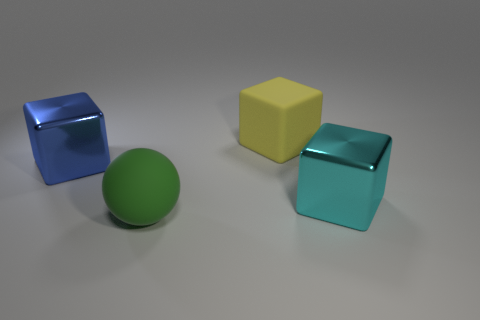Is there a blue thing of the same shape as the yellow matte thing?
Give a very brief answer. Yes. There is a large rubber block; does it have the same color as the cube that is on the left side of the big green matte sphere?
Keep it short and to the point. No. Is there a blue metallic block of the same size as the blue shiny thing?
Provide a succinct answer. No. Are the big yellow block and the cube to the left of the green matte ball made of the same material?
Your answer should be very brief. No. Is the number of yellow matte cylinders greater than the number of spheres?
Your response must be concise. No. How many balls are either small purple things or blue shiny objects?
Provide a succinct answer. 0. What color is the matte sphere?
Your response must be concise. Green. Do the metal object on the left side of the cyan cube and the thing behind the large blue cube have the same size?
Your response must be concise. Yes. Is the number of spheres less than the number of red rubber cubes?
Your answer should be compact. No. How many yellow rubber cubes are on the right side of the green rubber sphere?
Make the answer very short. 1. 